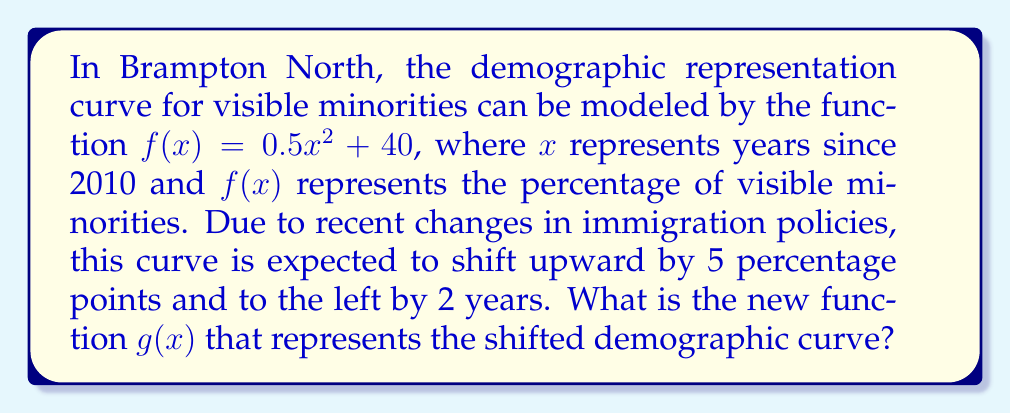Help me with this question. To solve this problem, we need to apply two transformations to the original function $f(x)$:

1. Vertical shift: The curve is shifting upward by 5 percentage points. This is represented by adding 5 to the function.
   $f(x) + 5$

2. Horizontal shift: The curve is shifting 2 years to the left. This is represented by replacing $x$ with $(x + 2)$.
   $f(x + 2)$

Combining these transformations:

$g(x) = f(x + 2) + 5$

Now, let's substitute the original function $f(x) = 0.5x^2 + 40$ into this equation:

$g(x) = [0.5(x + 2)^2 + 40] + 5$

Expanding the squared term:
$g(x) = [0.5(x^2 + 4x + 4) + 40] + 5$

$g(x) = 0.5x^2 + 2x + 2 + 40 + 5$

Simplifying:
$g(x) = 0.5x^2 + 2x + 47$

This is the new function representing the shifted demographic curve.
Answer: $g(x) = 0.5x^2 + 2x + 47$ 